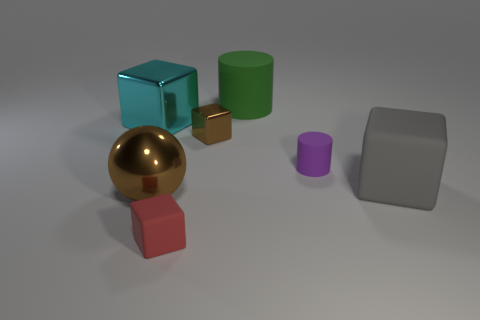Do the sphere and the tiny shiny cube have the same color?
Your answer should be very brief. Yes. Is the number of small purple cylinders that are in front of the small purple cylinder greater than the number of large cyan objects that are to the left of the cyan metallic cube?
Your answer should be compact. No. How many other objects are the same size as the brown metallic cube?
Your response must be concise. 2. There is a metal thing that is the same color as the metal sphere; what size is it?
Make the answer very short. Small. The big block to the right of the rubber block to the left of the small matte cylinder is made of what material?
Give a very brief answer. Rubber. Are there any cylinders to the left of the small cylinder?
Your answer should be compact. Yes. Is the number of big cyan objects to the right of the cyan object greater than the number of large gray rubber blocks?
Keep it short and to the point. No. Is there a matte cube that has the same color as the large ball?
Your answer should be compact. No. There is a sphere that is the same size as the green thing; what color is it?
Provide a succinct answer. Brown. There is a big block in front of the cyan thing; is there a sphere to the right of it?
Your answer should be very brief. No. 